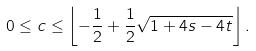Convert formula to latex. <formula><loc_0><loc_0><loc_500><loc_500>0 \leq c \leq \left \lfloor - \frac { 1 } { 2 } + \frac { 1 } { 2 } \sqrt { 1 + 4 s - 4 t } \right \rfloor .</formula> 